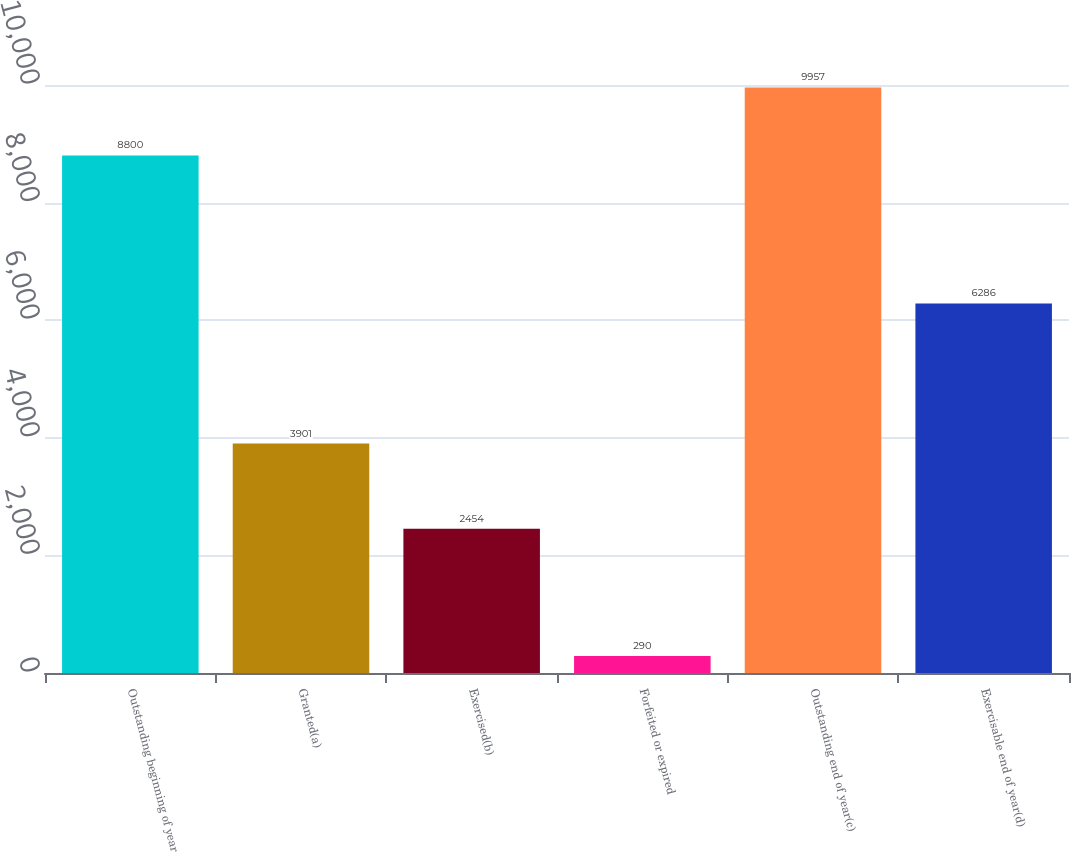<chart> <loc_0><loc_0><loc_500><loc_500><bar_chart><fcel>Outstanding beginning of year<fcel>Granted(a)<fcel>Exercised(b)<fcel>Forfeited or expired<fcel>Outstanding end of year(c)<fcel>Exercisable end of year(d)<nl><fcel>8800<fcel>3901<fcel>2454<fcel>290<fcel>9957<fcel>6286<nl></chart> 